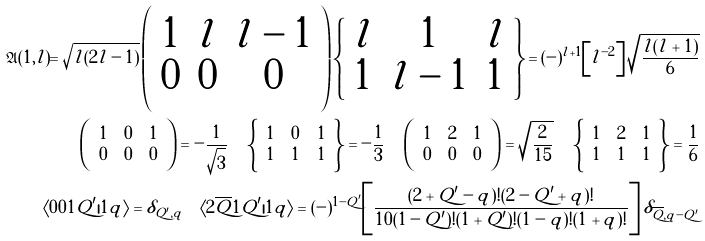Convert formula to latex. <formula><loc_0><loc_0><loc_500><loc_500>\mathfrak { A } ( 1 , l ) = \sqrt { l ( 2 l - 1 ) } \left ( \begin{array} { c c c } 1 & l & l - 1 \\ 0 & 0 & 0 \end{array} \right ) \left \{ \begin{array} { c c c } l & 1 & l \\ 1 & l - 1 & 1 \end{array} \right \} = ( - ) ^ { l + 1 } \left [ l ^ { - 2 } \right ] \sqrt { \frac { l ( l + 1 ) } { 6 } } \\ \left ( \begin{array} { c c c } 1 & 0 & 1 \\ 0 & 0 & 0 \end{array} \right ) = - \frac { 1 } { \sqrt { 3 } } \quad \left \{ \begin{array} { c c c } 1 & 0 & 1 \\ 1 & 1 & 1 \end{array} \right \} = - \frac { 1 } { 3 } \quad \left ( \begin{array} { c c c } 1 & 2 & 1 \\ 0 & 0 & 0 \end{array} \right ) = \sqrt { \frac { 2 } { 1 5 } } \quad \left \{ \begin{array} { c c c } 1 & 2 & 1 \\ 1 & 1 & 1 \end{array} \right \} = \frac { 1 } { 6 } \\ \langle 0 0 1 Q ^ { \prime } | 1 q \rangle = \delta _ { Q ^ { \prime } , q } \quad \langle 2 \overline { Q } 1 Q ^ { \prime } | 1 q \rangle = ( - ) ^ { 1 - Q ^ { \prime } } \left [ \frac { ( 2 + Q ^ { \prime } - q ) ! ( 2 - Q ^ { \prime } + q ) ! } { 1 0 ( 1 - Q ^ { \prime } ) ! ( 1 + Q ^ { \prime } ) ! ( 1 - q ) ! ( 1 + q ) ! } \right ] \delta _ { \overline { Q } , q - Q ^ { \prime } }</formula> 